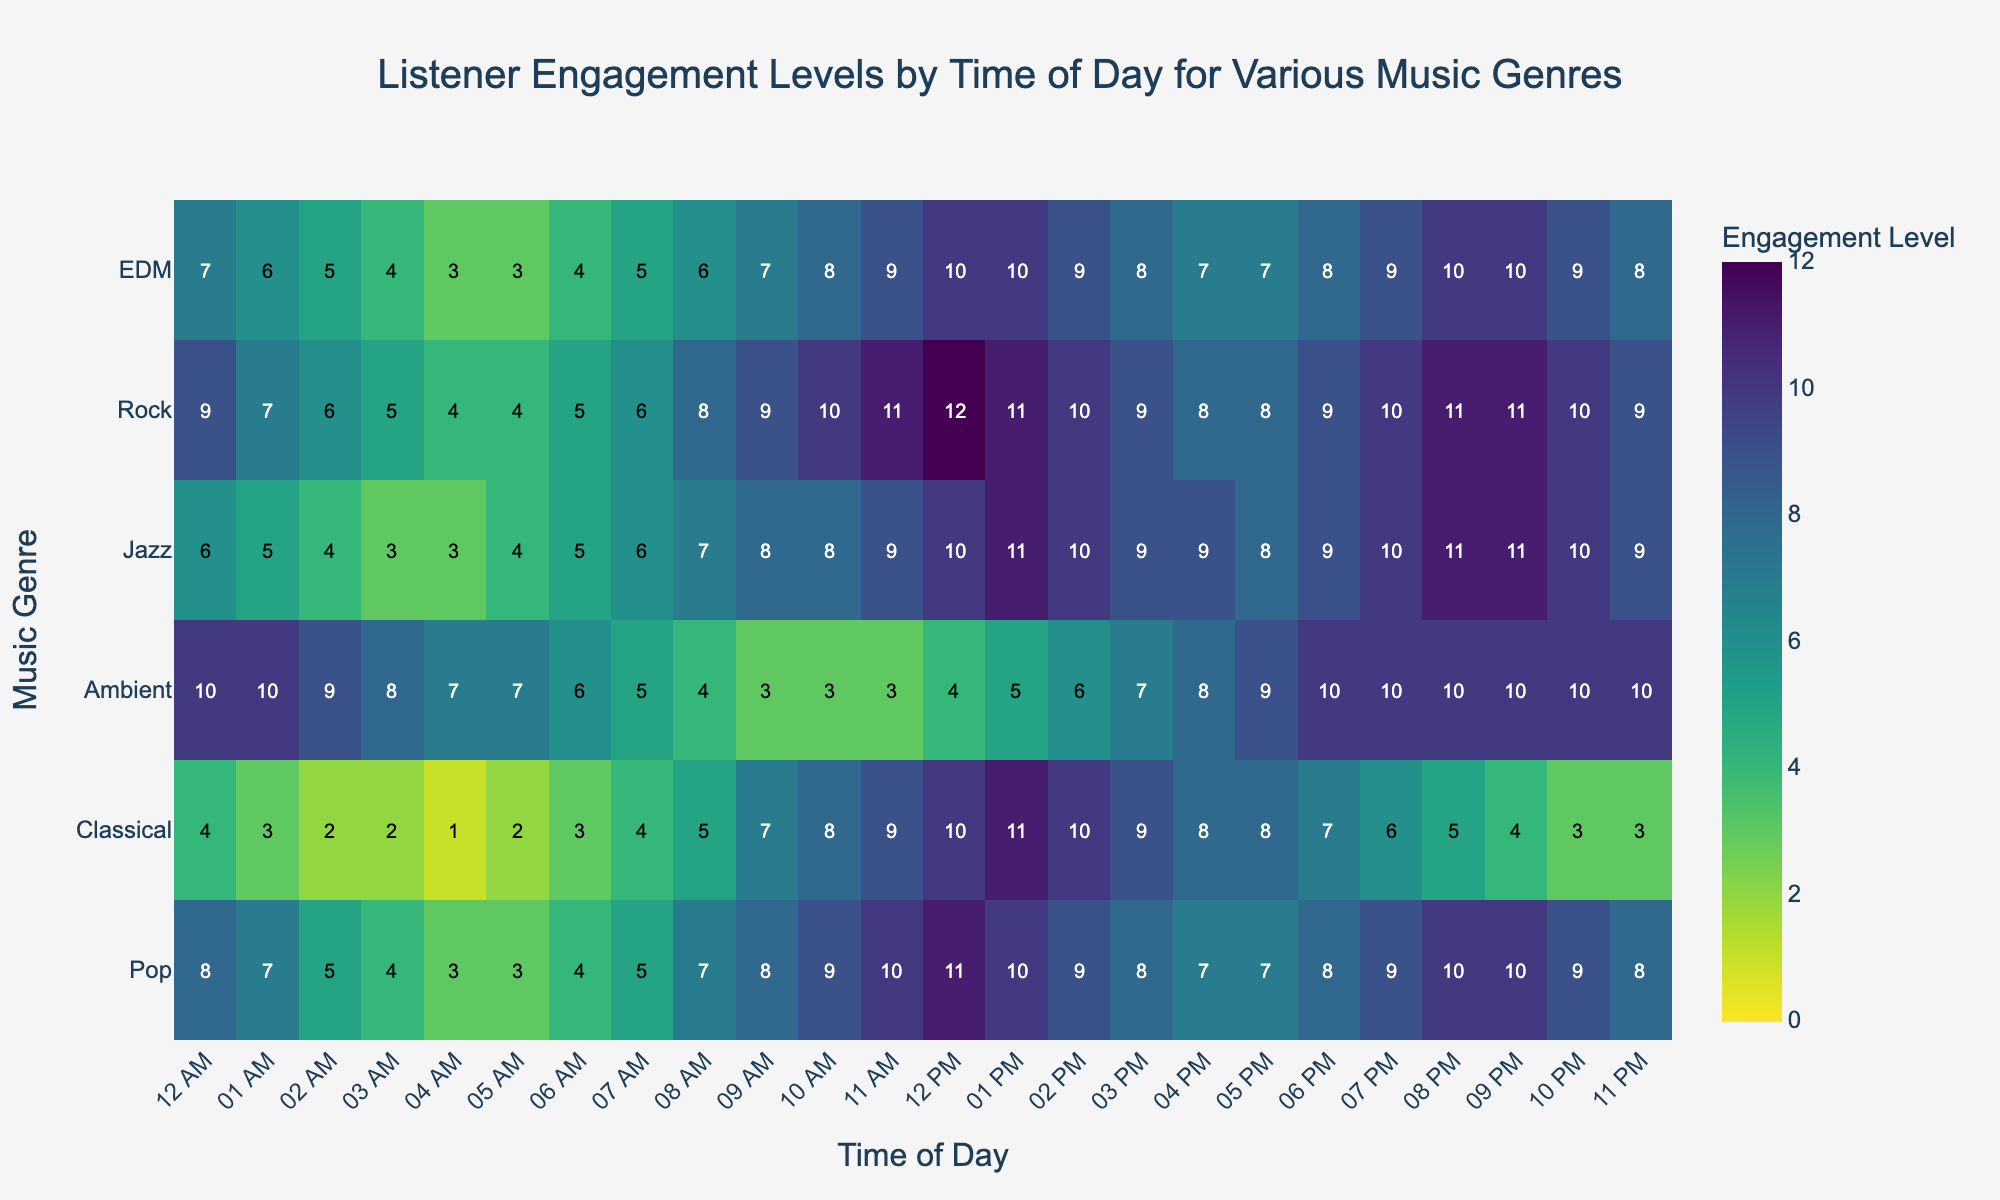What is the highest engagement level for Classical music? Look at the heatmap for Classical music and identify the highest number in its corresponding row.
Answer: 11 Which time of day has the highest engagement level for Ambient music? Find the peak value in the Ambient music row and note the time at the top of the corresponding column.
Answer: 12 PM During which time of day does Pop music have the lowest engagement level? Identify the lowest value in the row for Pop music and note the time at the top of the corresponding column.
Answer: 04 AM Which music genre has the highest listener engagement at 10 AM? Look at the 10 AM column and find the maximum value among all genres.
Answer: Rock What is the average engagement level for EDM between 6 AM and 6 PM? Sum the values for EDM from 6 AM to 6 PM and divide the sum by the number of values (13). This is the average. (4 + 5 + 6 + 7 + 8 + 9 + 10 + 10 + 9 + 8 + 7) / 11 = 83 / 11 = 7.55
Answer: 7.55 Which genre shows the most consistent engagement level throughout the day? Look across the rows and determine which genre has the least variation in engagement levels.
Answer: Ambient How does the engagement level for Jazz at 11 PM compare with that at 11 AM? Note the values for Jazz at 11 PM and 11 AM and compare them.
Answer: Equal What time of day generally shows a peak in listener engagement for most genres? Observe the time frames when most genres reach the higher engagement levels and identify a common time period.
Answer: 12 PM What is the difference in engagement level between Pop music and Classical music at 01:00? Subtract the value of Classical music at 01:00 from that of Pop music at the same time. 7 - 3 = 4
Answer: 4 Which two genres have the closest engagement levels at midnight (00:00)? Compare the values for each genre at 00:00 and identify the pair with the smallest difference.
Answer: EDM and Jazz 